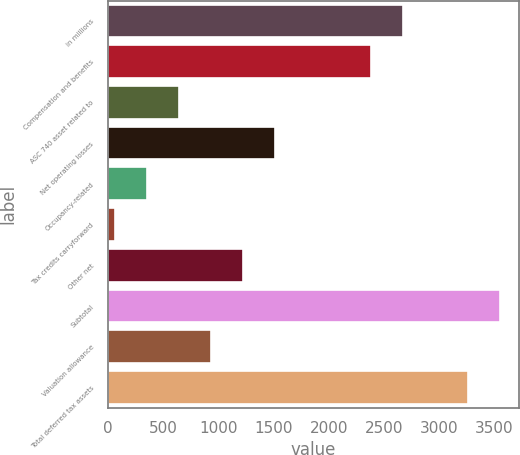Convert chart. <chart><loc_0><loc_0><loc_500><loc_500><bar_chart><fcel>in millions<fcel>Compensation and benefits<fcel>ASC 740 asset related to<fcel>Net operating losses<fcel>Occupancy-related<fcel>Tax credits carryforward<fcel>Other net<fcel>Subtotal<fcel>Valuation allowance<fcel>Total deferred tax assets<nl><fcel>2676.5<fcel>2386<fcel>643<fcel>1514.5<fcel>352.5<fcel>62<fcel>1224<fcel>3548<fcel>933.5<fcel>3257.5<nl></chart> 